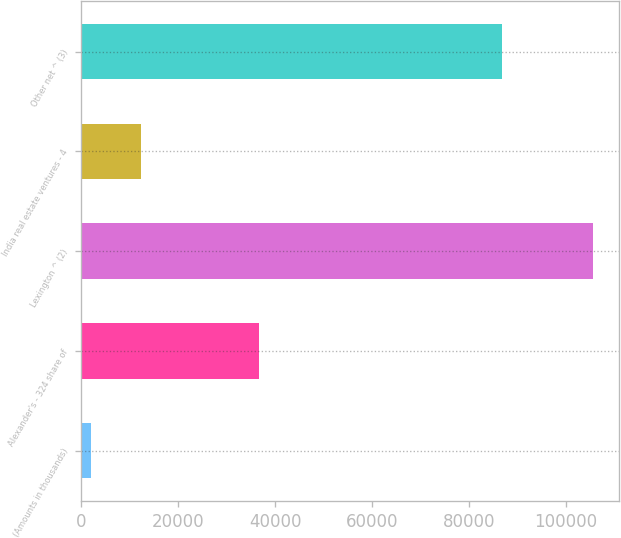<chart> <loc_0><loc_0><loc_500><loc_500><bar_chart><fcel>(Amounts in thousands)<fcel>Alexander's - 324 share of<fcel>Lexington ^ (2)<fcel>India real estate ventures - 4<fcel>Other net ^ (3)<nl><fcel>2008<fcel>36671<fcel>105630<fcel>12370.2<fcel>86912<nl></chart> 